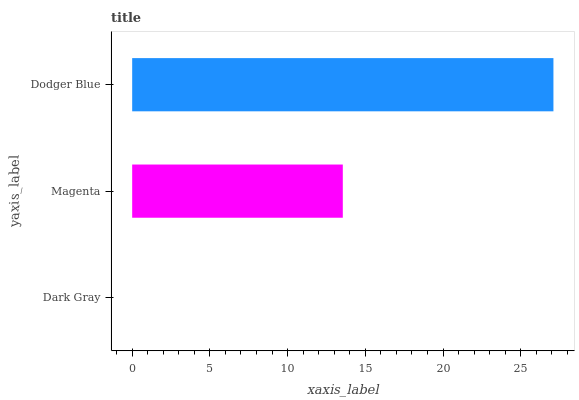Is Dark Gray the minimum?
Answer yes or no. Yes. Is Dodger Blue the maximum?
Answer yes or no. Yes. Is Magenta the minimum?
Answer yes or no. No. Is Magenta the maximum?
Answer yes or no. No. Is Magenta greater than Dark Gray?
Answer yes or no. Yes. Is Dark Gray less than Magenta?
Answer yes or no. Yes. Is Dark Gray greater than Magenta?
Answer yes or no. No. Is Magenta less than Dark Gray?
Answer yes or no. No. Is Magenta the high median?
Answer yes or no. Yes. Is Magenta the low median?
Answer yes or no. Yes. Is Dark Gray the high median?
Answer yes or no. No. Is Dark Gray the low median?
Answer yes or no. No. 